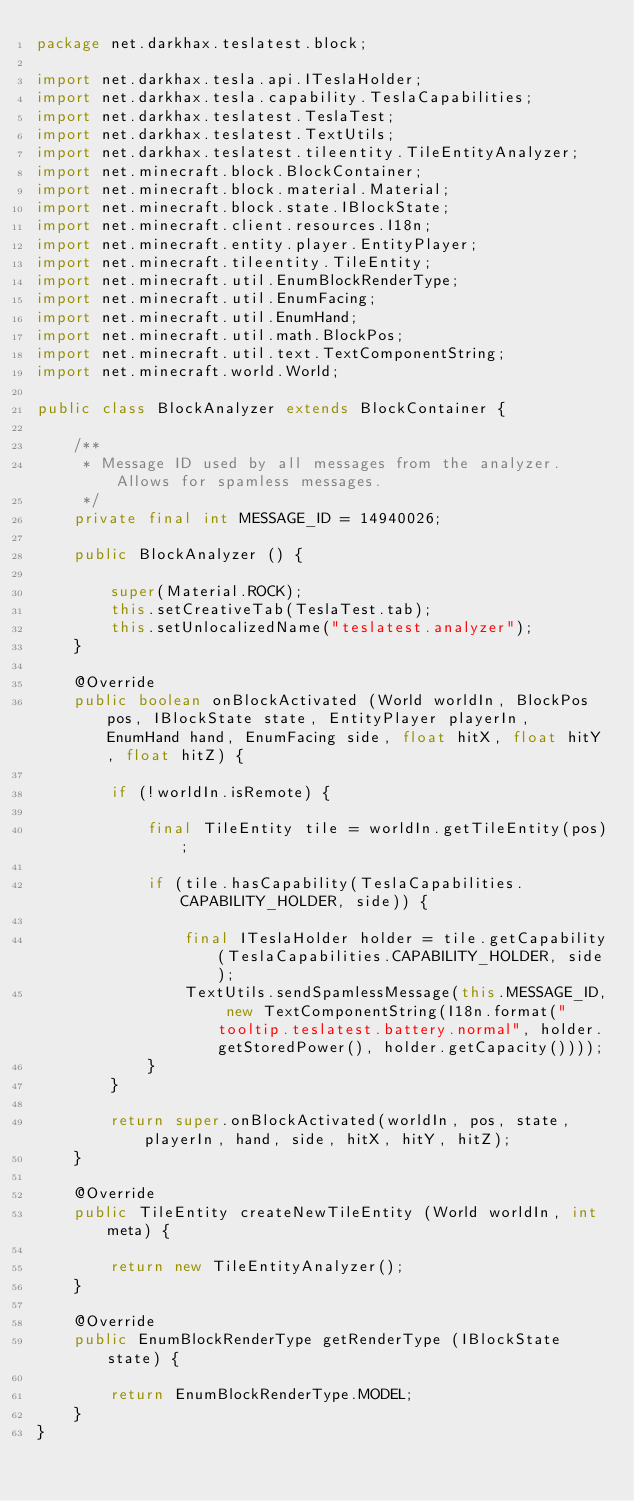<code> <loc_0><loc_0><loc_500><loc_500><_Java_>package net.darkhax.teslatest.block;

import net.darkhax.tesla.api.ITeslaHolder;
import net.darkhax.tesla.capability.TeslaCapabilities;
import net.darkhax.teslatest.TeslaTest;
import net.darkhax.teslatest.TextUtils;
import net.darkhax.teslatest.tileentity.TileEntityAnalyzer;
import net.minecraft.block.BlockContainer;
import net.minecraft.block.material.Material;
import net.minecraft.block.state.IBlockState;
import net.minecraft.client.resources.I18n;
import net.minecraft.entity.player.EntityPlayer;
import net.minecraft.tileentity.TileEntity;
import net.minecraft.util.EnumBlockRenderType;
import net.minecraft.util.EnumFacing;
import net.minecraft.util.EnumHand;
import net.minecraft.util.math.BlockPos;
import net.minecraft.util.text.TextComponentString;
import net.minecraft.world.World;

public class BlockAnalyzer extends BlockContainer {

    /**
     * Message ID used by all messages from the analyzer. Allows for spamless messages.
     */
    private final int MESSAGE_ID = 14940026;

    public BlockAnalyzer () {

        super(Material.ROCK);
        this.setCreativeTab(TeslaTest.tab);
        this.setUnlocalizedName("teslatest.analyzer");
    }

    @Override
    public boolean onBlockActivated (World worldIn, BlockPos pos, IBlockState state, EntityPlayer playerIn, EnumHand hand, EnumFacing side, float hitX, float hitY, float hitZ) {

        if (!worldIn.isRemote) {

            final TileEntity tile = worldIn.getTileEntity(pos);

            if (tile.hasCapability(TeslaCapabilities.CAPABILITY_HOLDER, side)) {

                final ITeslaHolder holder = tile.getCapability(TeslaCapabilities.CAPABILITY_HOLDER, side);
                TextUtils.sendSpamlessMessage(this.MESSAGE_ID, new TextComponentString(I18n.format("tooltip.teslatest.battery.normal", holder.getStoredPower(), holder.getCapacity())));
            }
        }

        return super.onBlockActivated(worldIn, pos, state, playerIn, hand, side, hitX, hitY, hitZ);
    }

    @Override
    public TileEntity createNewTileEntity (World worldIn, int meta) {

        return new TileEntityAnalyzer();
    }

    @Override
    public EnumBlockRenderType getRenderType (IBlockState state) {

        return EnumBlockRenderType.MODEL;
    }
}
</code> 